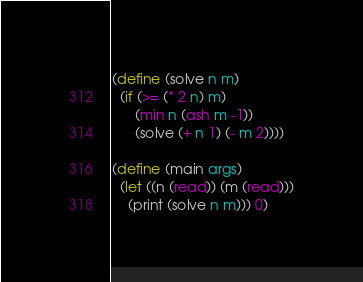<code> <loc_0><loc_0><loc_500><loc_500><_Scheme_>(define (solve n m)
  (if (>= (* 2 n) m)
      (min n (ash m -1))
      (solve (+ n 1) (- m 2))))

(define (main args)
  (let ((n (read)) (m (read)))
    (print (solve n m))) 0)
</code> 